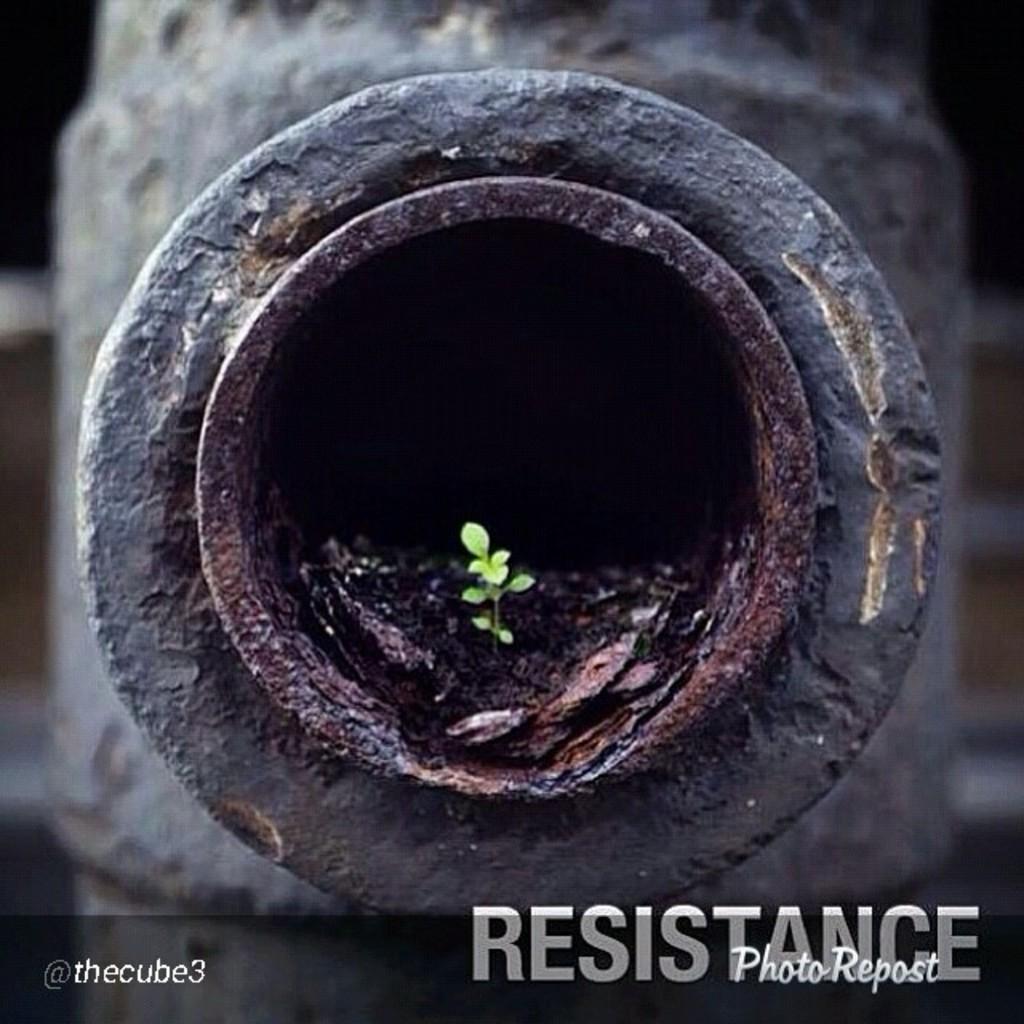Please provide a concise description of this image. Here in this picture we can see an iron pipe present over there and in the hole of it we can see a small plant present over there. 